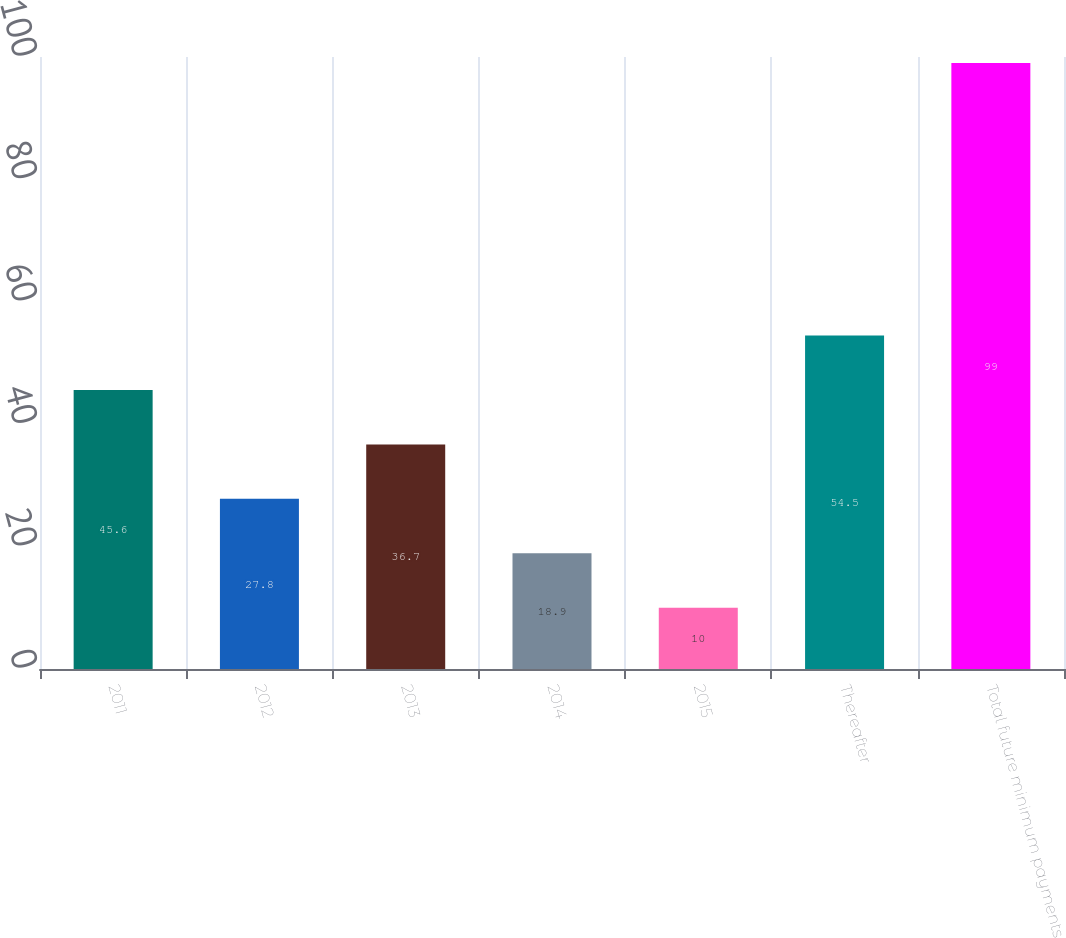Convert chart to OTSL. <chart><loc_0><loc_0><loc_500><loc_500><bar_chart><fcel>2011<fcel>2012<fcel>2013<fcel>2014<fcel>2015<fcel>Thereafter<fcel>Total future minimum payments<nl><fcel>45.6<fcel>27.8<fcel>36.7<fcel>18.9<fcel>10<fcel>54.5<fcel>99<nl></chart> 